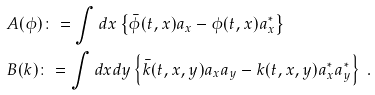<formula> <loc_0><loc_0><loc_500><loc_500>& \ A ( \phi ) \colon = \int d x \left \{ \bar { \phi } ( t , x ) a _ { x } - \phi ( t , x ) a ^ { \ast } _ { x } \right \} \\ & \ B ( k ) \colon = \int d x d y \left \{ \bar { k } ( t , x , y ) a _ { x } a _ { y } - k ( t , x , y ) a ^ { \ast } _ { x } a ^ { \ast } _ { y } \right \} \ .</formula> 